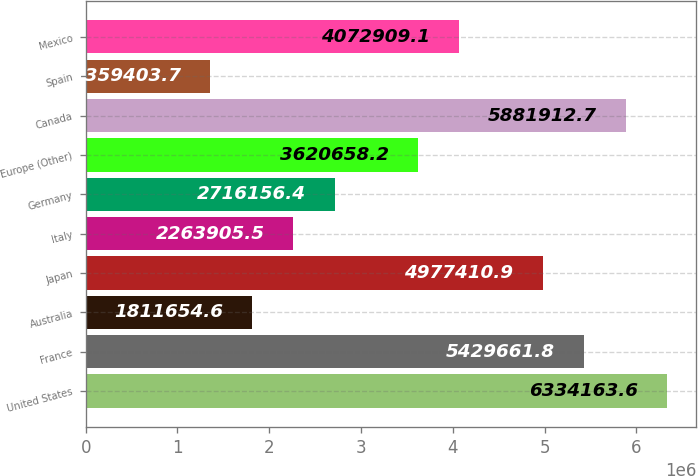Convert chart to OTSL. <chart><loc_0><loc_0><loc_500><loc_500><bar_chart><fcel>United States<fcel>France<fcel>Australia<fcel>Japan<fcel>Italy<fcel>Germany<fcel>Europe (Other)<fcel>Canada<fcel>Spain<fcel>Mexico<nl><fcel>6.33416e+06<fcel>5.42966e+06<fcel>1.81165e+06<fcel>4.97741e+06<fcel>2.26391e+06<fcel>2.71616e+06<fcel>3.62066e+06<fcel>5.88191e+06<fcel>1.3594e+06<fcel>4.07291e+06<nl></chart> 